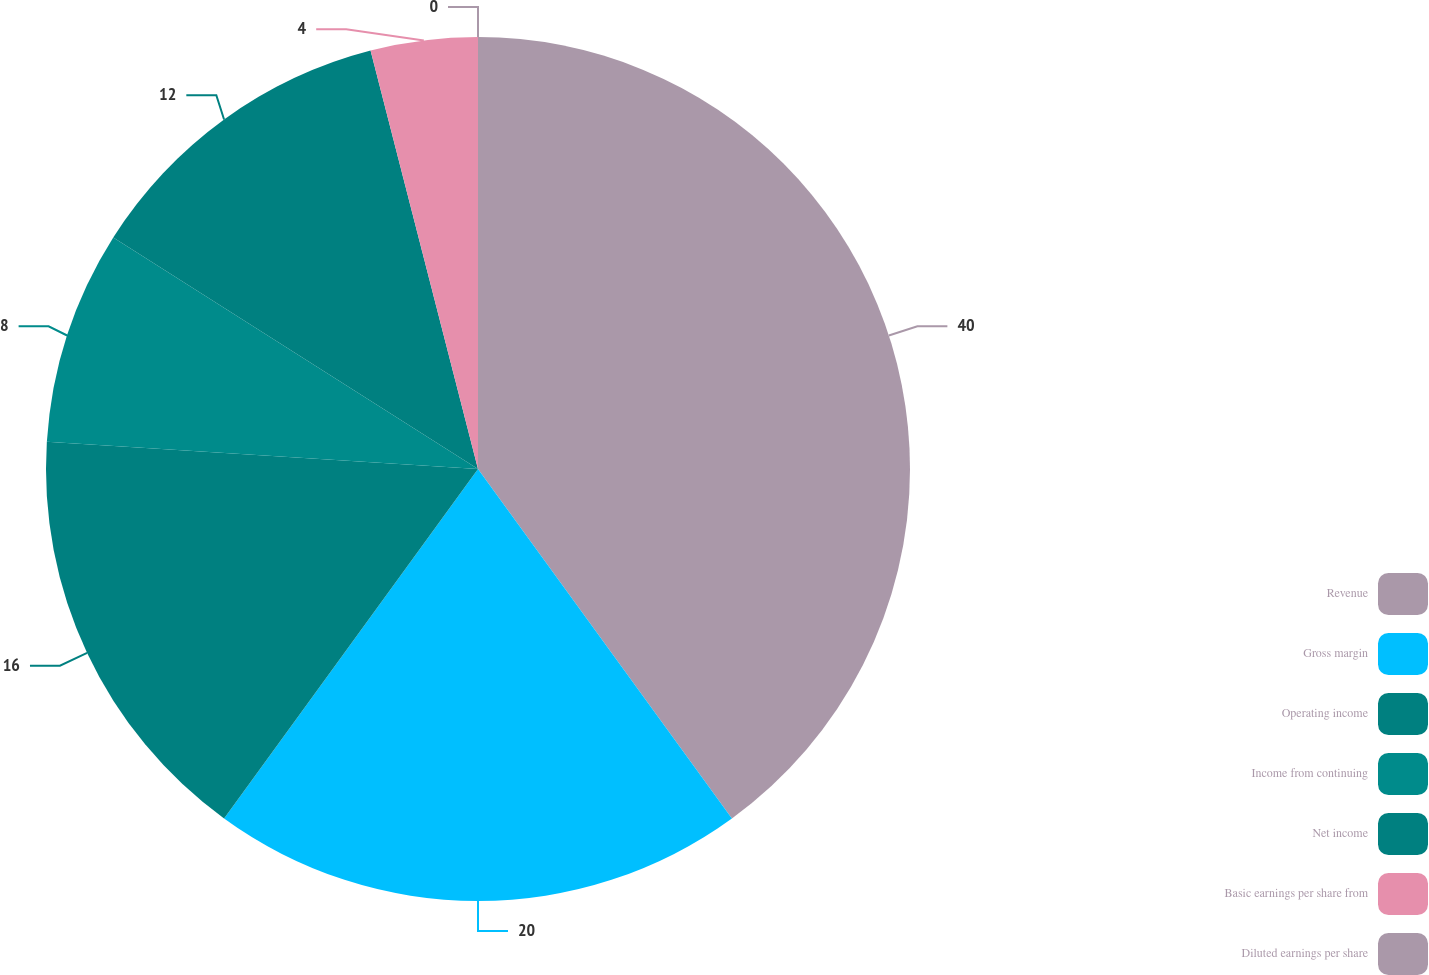Convert chart to OTSL. <chart><loc_0><loc_0><loc_500><loc_500><pie_chart><fcel>Revenue<fcel>Gross margin<fcel>Operating income<fcel>Income from continuing<fcel>Net income<fcel>Basic earnings per share from<fcel>Diluted earnings per share<nl><fcel>40.0%<fcel>20.0%<fcel>16.0%<fcel>8.0%<fcel>12.0%<fcel>4.0%<fcel>0.0%<nl></chart> 